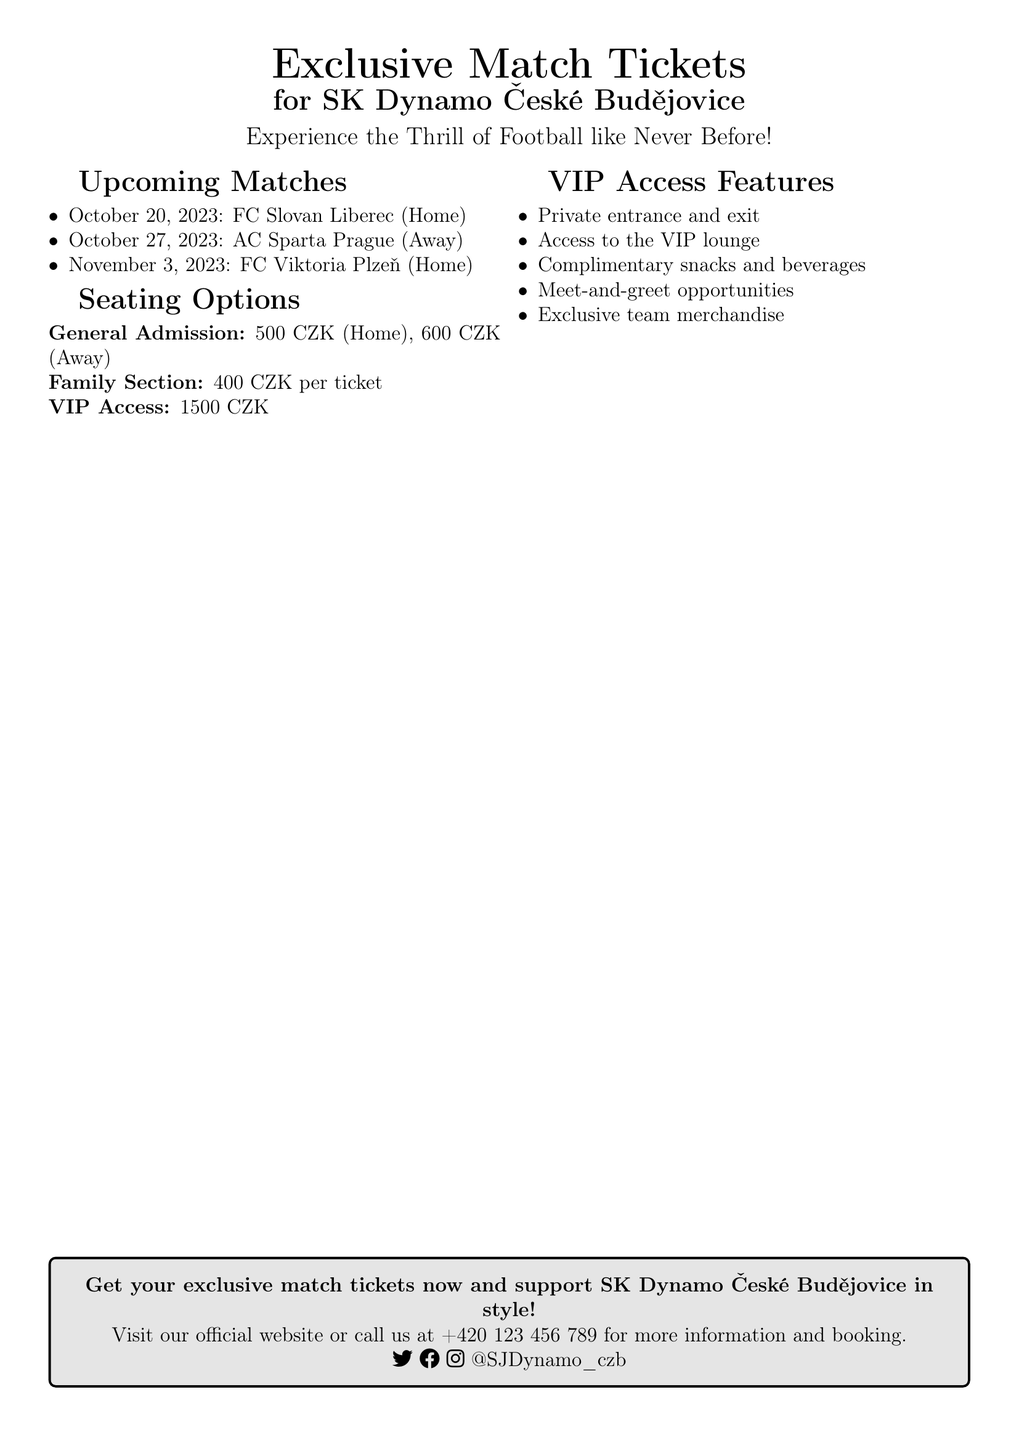What are the upcoming home matches? The document lists the upcoming matches, specifying which ones are home matches. The next home match is against FC Viktoria Plzeň.
Answer: FC Viktoria Plzeň How much is VIP access for a match? The document states the price for VIP access under the seating options section.
Answer: 1500 CZK What is the ticket price for General Admission away matches? The price for General Admission for away matches is clearly mentioned in the seating options.
Answer: 600 CZK What features are included with VIP access? The document lists various features available with VIP access, requiring an understanding of the benefits.
Answer: Private entrance and exit, access to the VIP lounge, complimentary snacks and beverages, meet-and-greet opportunities, exclusive team merchandise On what date is the match against AC Sparta Prague? The document provides specific dates for upcoming matches, including the one against AC Sparta Prague.
Answer: October 27, 2023 What is the ticket price for the Family Section? The document mentions the Family Section ticket price distinctly, making it easy to locate this information.
Answer: 400 CZK per ticket How can I get my tickets? The document includes information on how to obtain tickets, directing readers to the official website or a contact number.
Answer: Visit our official website or call +420 123 456 789 What color is the voucher’s design? The document likely uses team colors, which is a prominent feature of the voucher's design as stated.
Answer: Team colors 